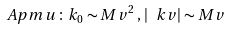<formula> <loc_0><loc_0><loc_500><loc_500>\ A p m u \, \colon \, k _ { 0 } \sim M v ^ { 2 } \, , \, | \ k v | \sim M v</formula> 